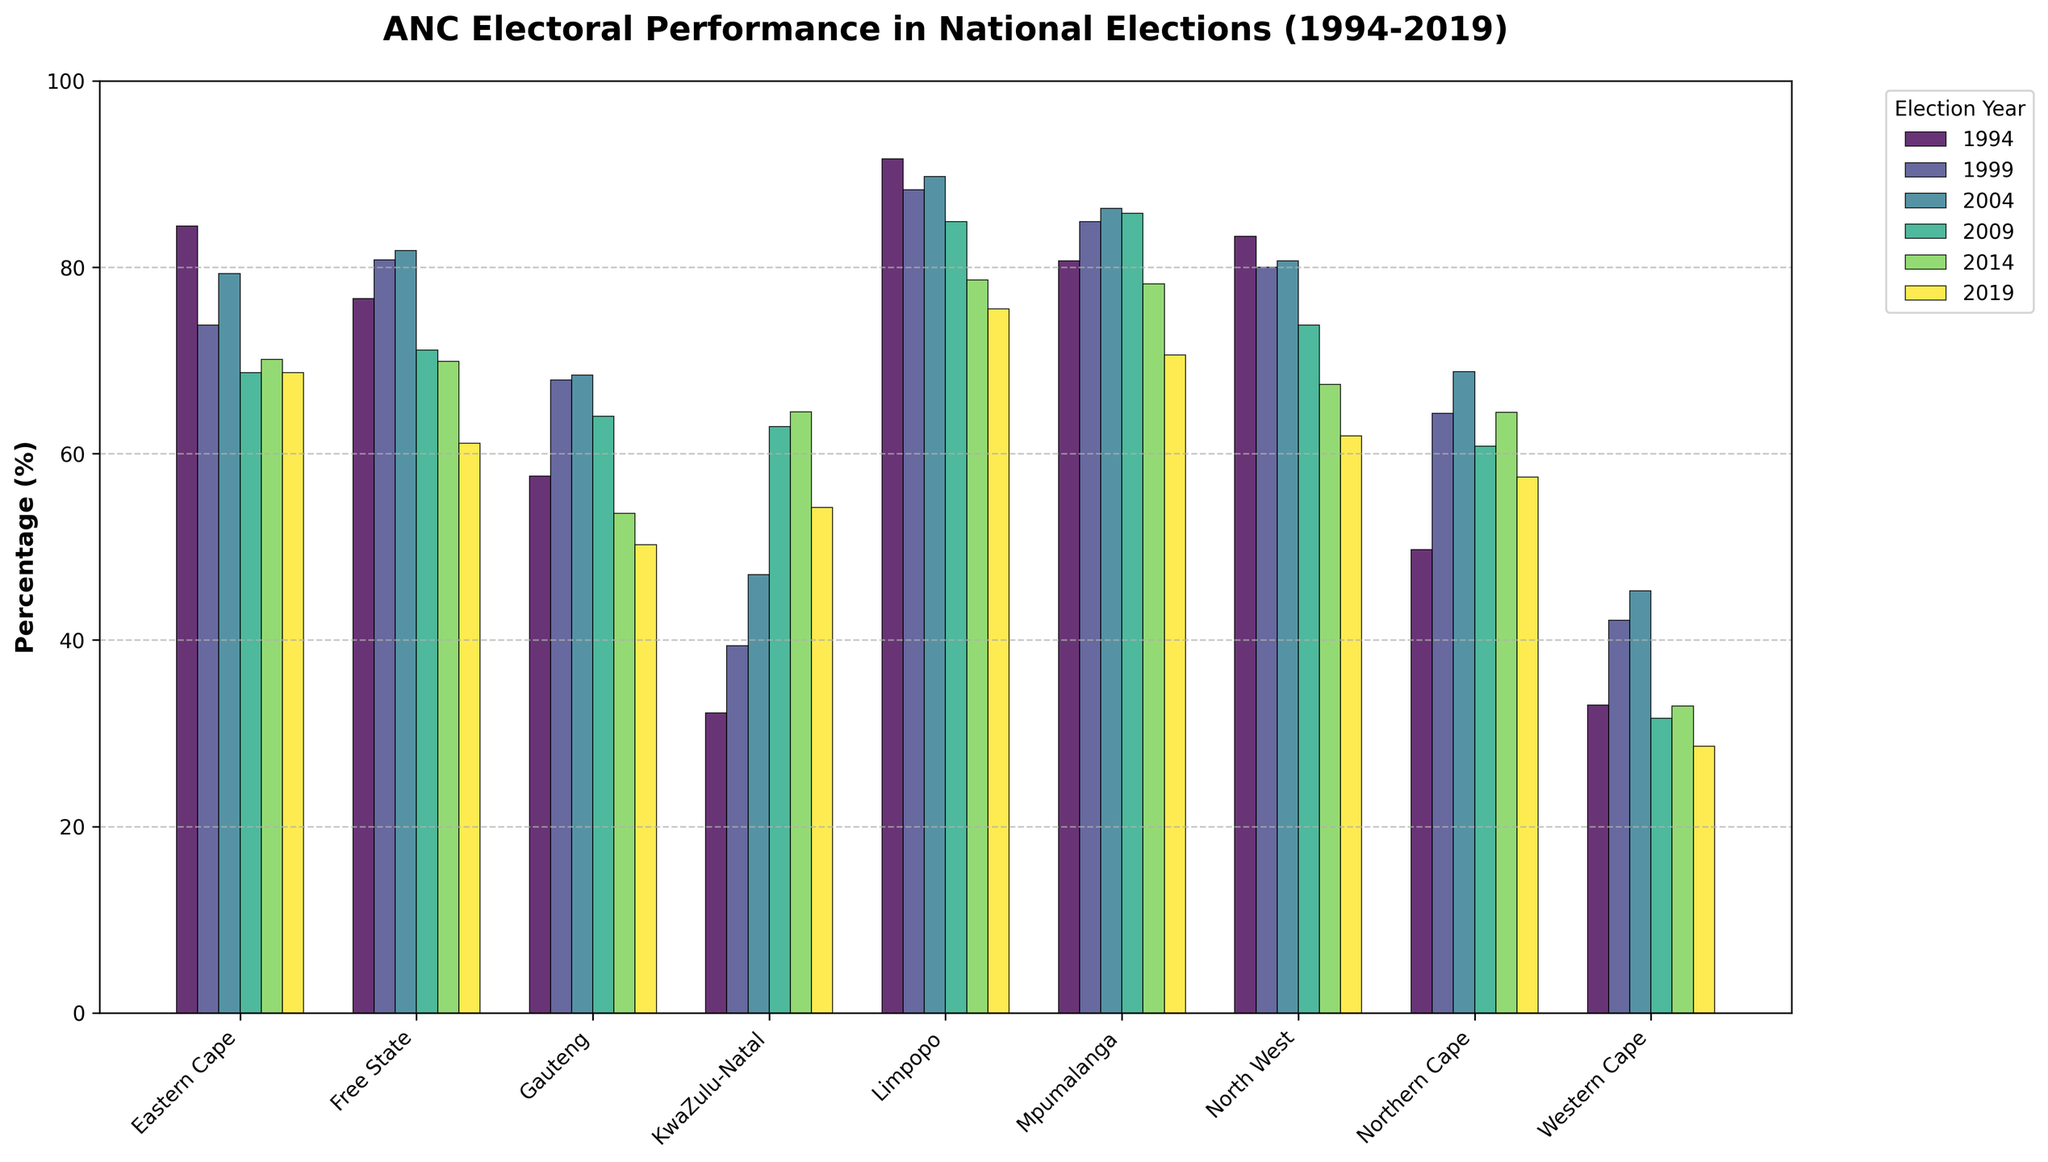Which province had the highest ANC electoral performance in 1994? The bar for Limpopo is the tallest in 1994, indicating the highest performance.
Answer: Limpopo How did the ANC's performance in the Western Cape change from 1994 to 2019? Identify the bars for 1994 and 2019 in the Western Cape section, note the percentage in 1994 was higher than in 2019 (33.0% vs. 28.6%).
Answer: It decreased In which year did the ANC receive the highest percentage of votes in Gauteng? Compare all the bars for Gauteng across the years, identifying the tallest bar which corresponds to 2004 at 68.4%.
Answer: 2004 Which province showed a continuous decline in ANC's performance from 2009 to 2019? Observe each province's bars from 2009, noting the continuous decreasing trend; Free State, Gauteng, and Mpumalanga fit.
Answer: Free State or Gauteng or Mpumalanga What was the average ANC vote percentage in KwaZulu-Natal from 1994 to 2019? Calculate the mean of the percentages: (32.2 + 39.4 + 47.0 + 62.9 + 64.5 + 54.2) / 6 = 50.03%.
Answer: 50.03% How did the ANC's performance in the Free State in 2019 compare to 2004? Compare the heights of Free State bars for 2004 and 2019, noting a decrease from 81.8% to 61.1%.
Answer: It declined Which years did ANC show increased performance in the Eastern Cape? Check bars for the years in Eastern Cape where percentages increased: an increase from 1999 to 2004 (73.8% to 79.3%).
Answer: 1999-2004 What is the difference in ANC performance between the Northern Cape and Western Cape in 1999? Subtract the 1999 Western Cape percentage from Northern Cape's (64.3% - 42.1% = 22.2%).
Answer: 22.2% Which province had the most significant drop in ANC performance between 2014 and 2019? Determine by visual inspection of the bar height differences; Free State shows the largest drop (69.9% to 61.1%).
Answer: Free State What was the trend for ANC's performance in Limpopo from 1994 to 2019? Observe the bars for Limpopo across the years, noting a general downward trend from a high of 91.6% in 1994 to 75.5% in 2019.
Answer: Downward trend 